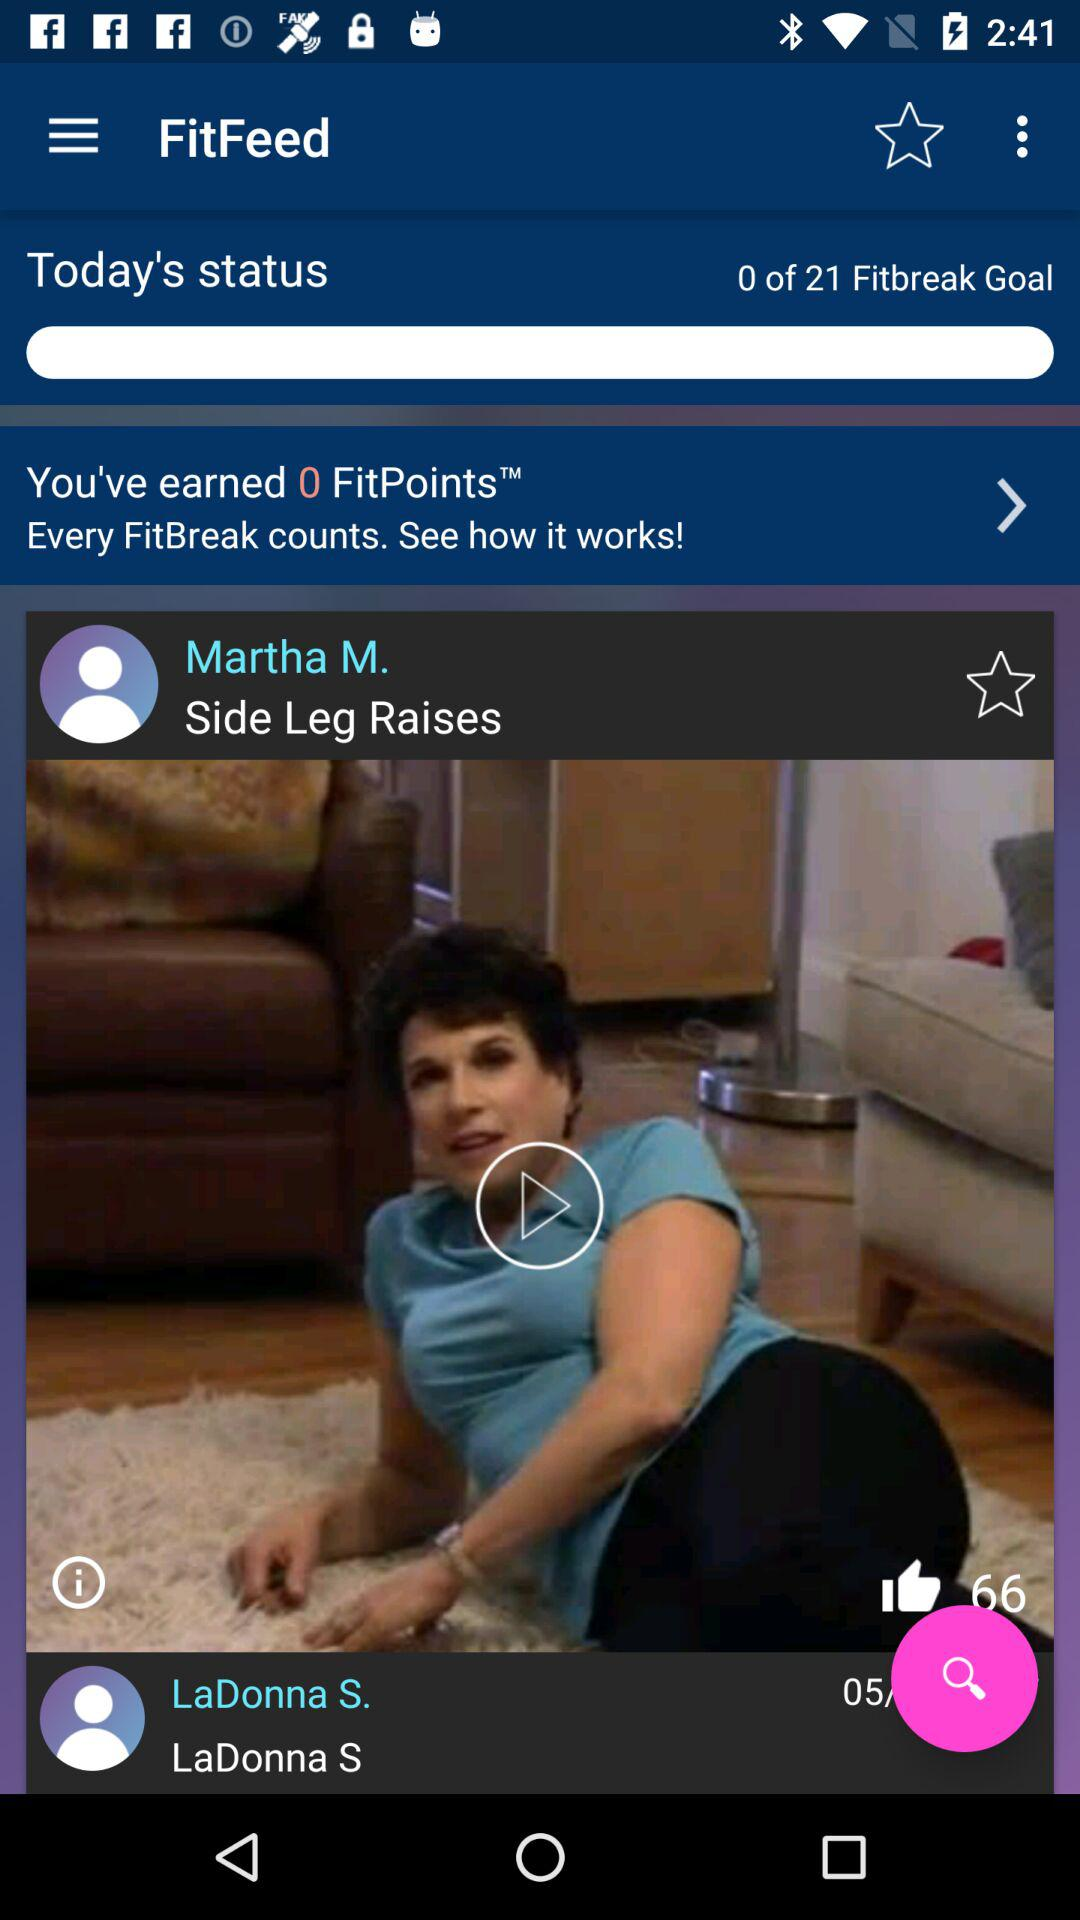How many "FitPoints" are earned by the user? The user earned 0 "FitPoints". 